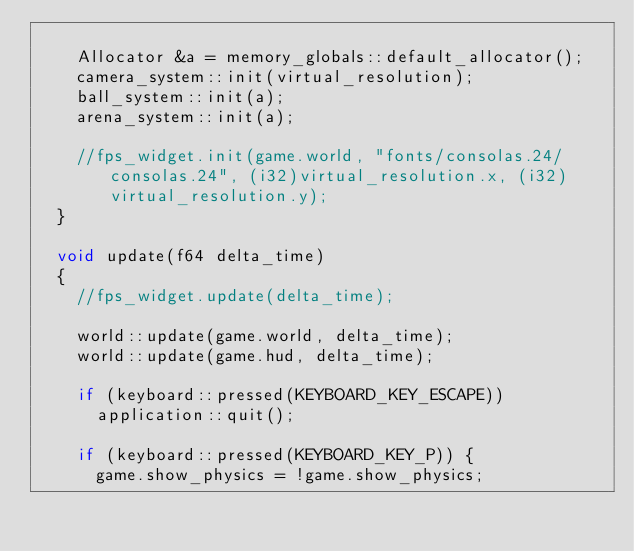<code> <loc_0><loc_0><loc_500><loc_500><_C++_>
    Allocator &a = memory_globals::default_allocator();
    camera_system::init(virtual_resolution);
    ball_system::init(a);
    arena_system::init(a);

    //fps_widget.init(game.world, "fonts/consolas.24/consolas.24", (i32)virtual_resolution.x, (i32)virtual_resolution.y);
  }

  void update(f64 delta_time)
  {
    //fps_widget.update(delta_time);

    world::update(game.world, delta_time);
    world::update(game.hud, delta_time);

    if (keyboard::pressed(KEYBOARD_KEY_ESCAPE))
      application::quit();

    if (keyboard::pressed(KEYBOARD_KEY_P)) {
      game.show_physics = !game.show_physics;</code> 